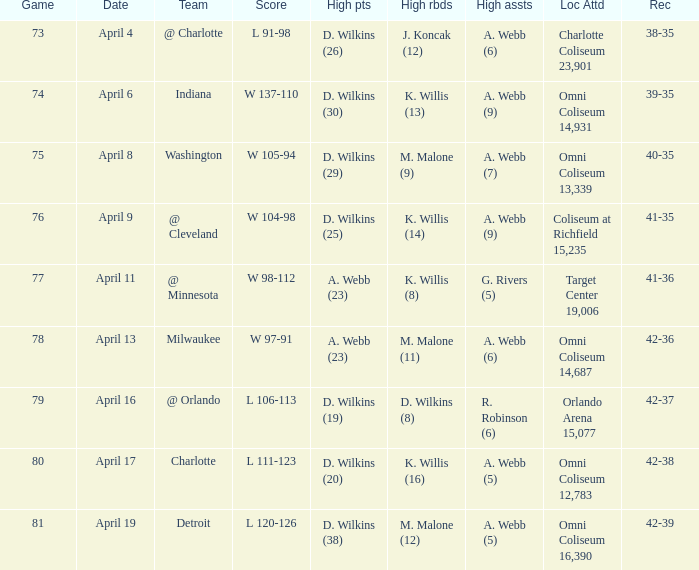Who had the high assists when the opponent was Indiana? A. Webb (9). Could you help me parse every detail presented in this table? {'header': ['Game', 'Date', 'Team', 'Score', 'High pts', 'High rbds', 'High assts', 'Loc Attd', 'Rec'], 'rows': [['73', 'April 4', '@ Charlotte', 'L 91-98', 'D. Wilkins (26)', 'J. Koncak (12)', 'A. Webb (6)', 'Charlotte Coliseum 23,901', '38-35'], ['74', 'April 6', 'Indiana', 'W 137-110', 'D. Wilkins (30)', 'K. Willis (13)', 'A. Webb (9)', 'Omni Coliseum 14,931', '39-35'], ['75', 'April 8', 'Washington', 'W 105-94', 'D. Wilkins (29)', 'M. Malone (9)', 'A. Webb (7)', 'Omni Coliseum 13,339', '40-35'], ['76', 'April 9', '@ Cleveland', 'W 104-98', 'D. Wilkins (25)', 'K. Willis (14)', 'A. Webb (9)', 'Coliseum at Richfield 15,235', '41-35'], ['77', 'April 11', '@ Minnesota', 'W 98-112', 'A. Webb (23)', 'K. Willis (8)', 'G. Rivers (5)', 'Target Center 19,006', '41-36'], ['78', 'April 13', 'Milwaukee', 'W 97-91', 'A. Webb (23)', 'M. Malone (11)', 'A. Webb (6)', 'Omni Coliseum 14,687', '42-36'], ['79', 'April 16', '@ Orlando', 'L 106-113', 'D. Wilkins (19)', 'D. Wilkins (8)', 'R. Robinson (6)', 'Orlando Arena 15,077', '42-37'], ['80', 'April 17', 'Charlotte', 'L 111-123', 'D. Wilkins (20)', 'K. Willis (16)', 'A. Webb (5)', 'Omni Coliseum 12,783', '42-38'], ['81', 'April 19', 'Detroit', 'L 120-126', 'D. Wilkins (38)', 'M. Malone (12)', 'A. Webb (5)', 'Omni Coliseum 16,390', '42-39']]} 